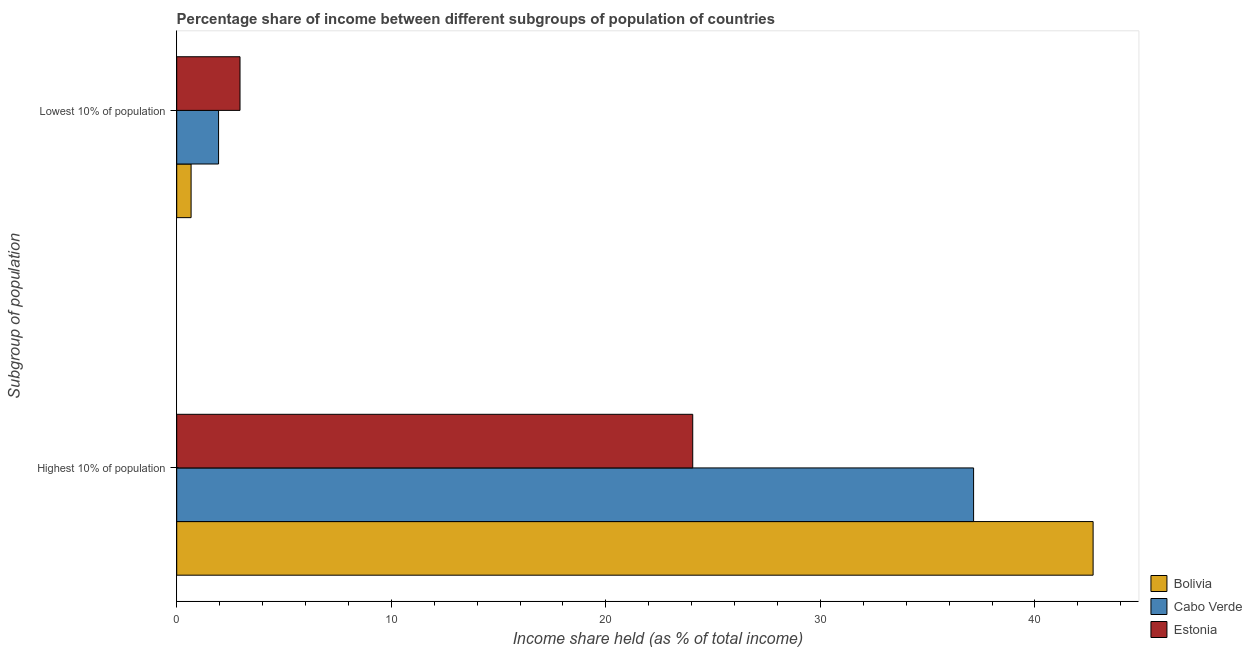How many bars are there on the 1st tick from the top?
Offer a terse response. 3. What is the label of the 1st group of bars from the top?
Make the answer very short. Lowest 10% of population. What is the income share held by lowest 10% of the population in Bolivia?
Ensure brevity in your answer.  0.67. Across all countries, what is the maximum income share held by lowest 10% of the population?
Offer a terse response. 2.95. Across all countries, what is the minimum income share held by highest 10% of the population?
Your response must be concise. 24.05. In which country was the income share held by lowest 10% of the population maximum?
Give a very brief answer. Estonia. In which country was the income share held by highest 10% of the population minimum?
Your answer should be very brief. Estonia. What is the total income share held by lowest 10% of the population in the graph?
Your response must be concise. 5.57. What is the difference between the income share held by lowest 10% of the population in Cabo Verde and that in Estonia?
Keep it short and to the point. -1. What is the difference between the income share held by lowest 10% of the population in Cabo Verde and the income share held by highest 10% of the population in Bolivia?
Provide a succinct answer. -40.76. What is the average income share held by highest 10% of the population per country?
Your answer should be compact. 34.63. What is the difference between the income share held by highest 10% of the population and income share held by lowest 10% of the population in Estonia?
Provide a short and direct response. 21.1. In how many countries, is the income share held by highest 10% of the population greater than 12 %?
Your answer should be very brief. 3. What is the ratio of the income share held by highest 10% of the population in Estonia to that in Bolivia?
Offer a very short reply. 0.56. Is the income share held by lowest 10% of the population in Bolivia less than that in Estonia?
Provide a short and direct response. Yes. What does the 2nd bar from the top in Highest 10% of population represents?
Make the answer very short. Cabo Verde. Are all the bars in the graph horizontal?
Offer a terse response. Yes. What is the difference between two consecutive major ticks on the X-axis?
Provide a succinct answer. 10. Are the values on the major ticks of X-axis written in scientific E-notation?
Give a very brief answer. No. Does the graph contain any zero values?
Offer a terse response. No. Does the graph contain grids?
Ensure brevity in your answer.  No. Where does the legend appear in the graph?
Your answer should be very brief. Bottom right. How are the legend labels stacked?
Your answer should be compact. Vertical. What is the title of the graph?
Provide a short and direct response. Percentage share of income between different subgroups of population of countries. What is the label or title of the X-axis?
Provide a succinct answer. Income share held (as % of total income). What is the label or title of the Y-axis?
Ensure brevity in your answer.  Subgroup of population. What is the Income share held (as % of total income) of Bolivia in Highest 10% of population?
Give a very brief answer. 42.71. What is the Income share held (as % of total income) in Cabo Verde in Highest 10% of population?
Give a very brief answer. 37.14. What is the Income share held (as % of total income) of Estonia in Highest 10% of population?
Offer a very short reply. 24.05. What is the Income share held (as % of total income) in Bolivia in Lowest 10% of population?
Provide a short and direct response. 0.67. What is the Income share held (as % of total income) in Cabo Verde in Lowest 10% of population?
Give a very brief answer. 1.95. What is the Income share held (as % of total income) in Estonia in Lowest 10% of population?
Give a very brief answer. 2.95. Across all Subgroup of population, what is the maximum Income share held (as % of total income) of Bolivia?
Give a very brief answer. 42.71. Across all Subgroup of population, what is the maximum Income share held (as % of total income) in Cabo Verde?
Make the answer very short. 37.14. Across all Subgroup of population, what is the maximum Income share held (as % of total income) in Estonia?
Provide a succinct answer. 24.05. Across all Subgroup of population, what is the minimum Income share held (as % of total income) of Bolivia?
Your response must be concise. 0.67. Across all Subgroup of population, what is the minimum Income share held (as % of total income) of Cabo Verde?
Provide a succinct answer. 1.95. Across all Subgroup of population, what is the minimum Income share held (as % of total income) of Estonia?
Give a very brief answer. 2.95. What is the total Income share held (as % of total income) of Bolivia in the graph?
Provide a short and direct response. 43.38. What is the total Income share held (as % of total income) of Cabo Verde in the graph?
Provide a succinct answer. 39.09. What is the difference between the Income share held (as % of total income) of Bolivia in Highest 10% of population and that in Lowest 10% of population?
Make the answer very short. 42.04. What is the difference between the Income share held (as % of total income) of Cabo Verde in Highest 10% of population and that in Lowest 10% of population?
Offer a very short reply. 35.19. What is the difference between the Income share held (as % of total income) in Estonia in Highest 10% of population and that in Lowest 10% of population?
Provide a succinct answer. 21.1. What is the difference between the Income share held (as % of total income) of Bolivia in Highest 10% of population and the Income share held (as % of total income) of Cabo Verde in Lowest 10% of population?
Provide a short and direct response. 40.76. What is the difference between the Income share held (as % of total income) in Bolivia in Highest 10% of population and the Income share held (as % of total income) in Estonia in Lowest 10% of population?
Your answer should be compact. 39.76. What is the difference between the Income share held (as % of total income) of Cabo Verde in Highest 10% of population and the Income share held (as % of total income) of Estonia in Lowest 10% of population?
Provide a succinct answer. 34.19. What is the average Income share held (as % of total income) of Bolivia per Subgroup of population?
Give a very brief answer. 21.69. What is the average Income share held (as % of total income) in Cabo Verde per Subgroup of population?
Your response must be concise. 19.55. What is the difference between the Income share held (as % of total income) in Bolivia and Income share held (as % of total income) in Cabo Verde in Highest 10% of population?
Offer a terse response. 5.57. What is the difference between the Income share held (as % of total income) of Bolivia and Income share held (as % of total income) of Estonia in Highest 10% of population?
Offer a terse response. 18.66. What is the difference between the Income share held (as % of total income) of Cabo Verde and Income share held (as % of total income) of Estonia in Highest 10% of population?
Your response must be concise. 13.09. What is the difference between the Income share held (as % of total income) of Bolivia and Income share held (as % of total income) of Cabo Verde in Lowest 10% of population?
Your answer should be very brief. -1.28. What is the difference between the Income share held (as % of total income) in Bolivia and Income share held (as % of total income) in Estonia in Lowest 10% of population?
Provide a short and direct response. -2.28. What is the ratio of the Income share held (as % of total income) of Bolivia in Highest 10% of population to that in Lowest 10% of population?
Give a very brief answer. 63.75. What is the ratio of the Income share held (as % of total income) of Cabo Verde in Highest 10% of population to that in Lowest 10% of population?
Your response must be concise. 19.05. What is the ratio of the Income share held (as % of total income) of Estonia in Highest 10% of population to that in Lowest 10% of population?
Your answer should be very brief. 8.15. What is the difference between the highest and the second highest Income share held (as % of total income) of Bolivia?
Provide a succinct answer. 42.04. What is the difference between the highest and the second highest Income share held (as % of total income) of Cabo Verde?
Keep it short and to the point. 35.19. What is the difference between the highest and the second highest Income share held (as % of total income) of Estonia?
Provide a short and direct response. 21.1. What is the difference between the highest and the lowest Income share held (as % of total income) in Bolivia?
Your answer should be very brief. 42.04. What is the difference between the highest and the lowest Income share held (as % of total income) in Cabo Verde?
Offer a very short reply. 35.19. What is the difference between the highest and the lowest Income share held (as % of total income) of Estonia?
Make the answer very short. 21.1. 